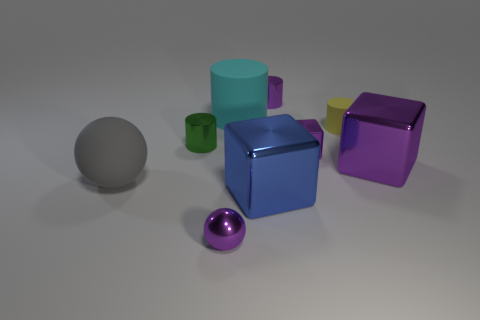What is the shape of the big object that is the same color as the small metallic block?
Offer a terse response. Cube. Does the gray thing have the same size as the blue metal object?
Make the answer very short. Yes. How many objects are green things or large metal cubes on the right side of the tiny purple cylinder?
Your response must be concise. 2. The big rubber thing in front of the tiny metal cylinder that is on the left side of the tiny purple sphere is what color?
Provide a short and direct response. Gray. There is a shiny ball that is in front of the cyan rubber thing; is its color the same as the small cube?
Keep it short and to the point. Yes. There is a tiny object that is in front of the big blue shiny cube; what is its material?
Provide a short and direct response. Metal. The cyan cylinder is what size?
Provide a short and direct response. Large. Is the material of the tiny object that is right of the tiny metal block the same as the small sphere?
Keep it short and to the point. No. What number of large yellow rubber objects are there?
Give a very brief answer. 0. What number of objects are either small metallic cubes or large matte things?
Your answer should be compact. 3. 